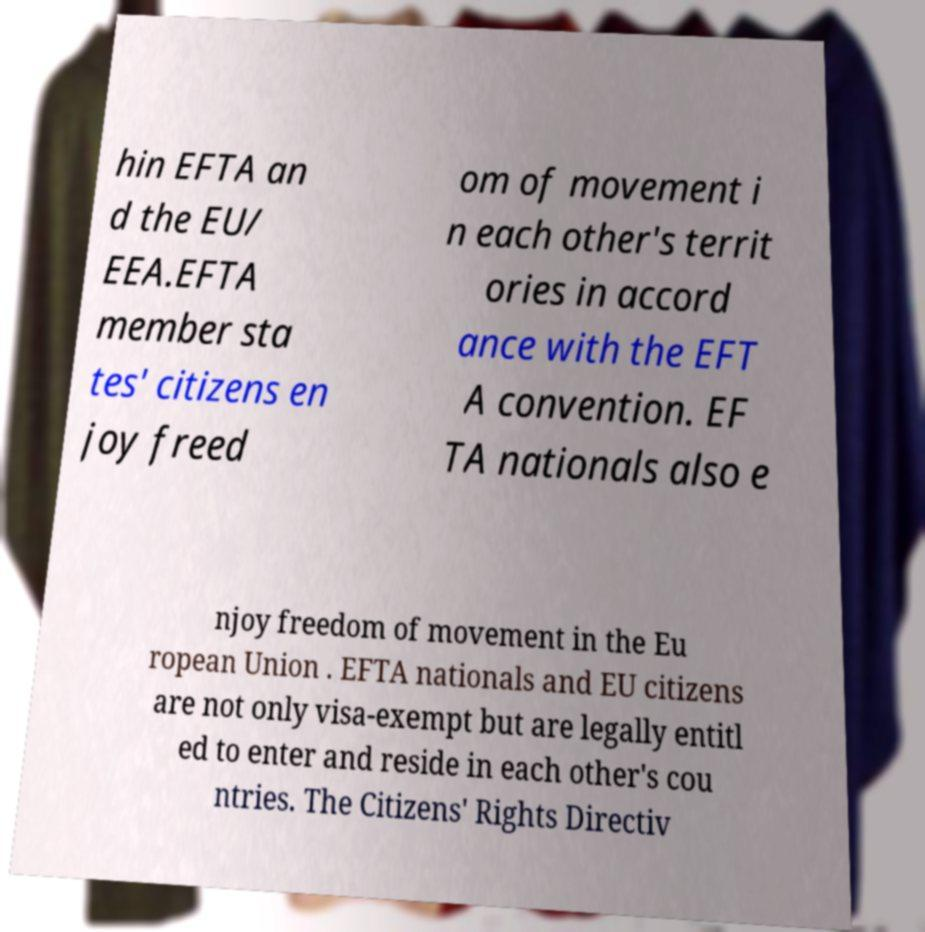I need the written content from this picture converted into text. Can you do that? hin EFTA an d the EU/ EEA.EFTA member sta tes' citizens en joy freed om of movement i n each other's territ ories in accord ance with the EFT A convention. EF TA nationals also e njoy freedom of movement in the Eu ropean Union . EFTA nationals and EU citizens are not only visa-exempt but are legally entitl ed to enter and reside in each other's cou ntries. The Citizens' Rights Directiv 